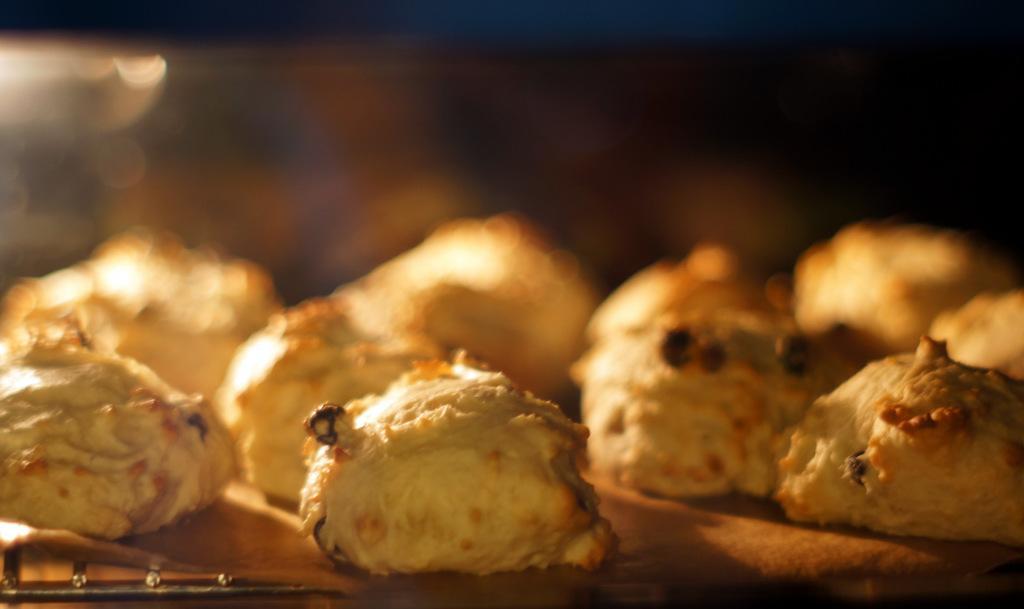Describe this image in one or two sentences. In this image the background is a little blurred. In the middle of the image there are few cookies on the tray. 